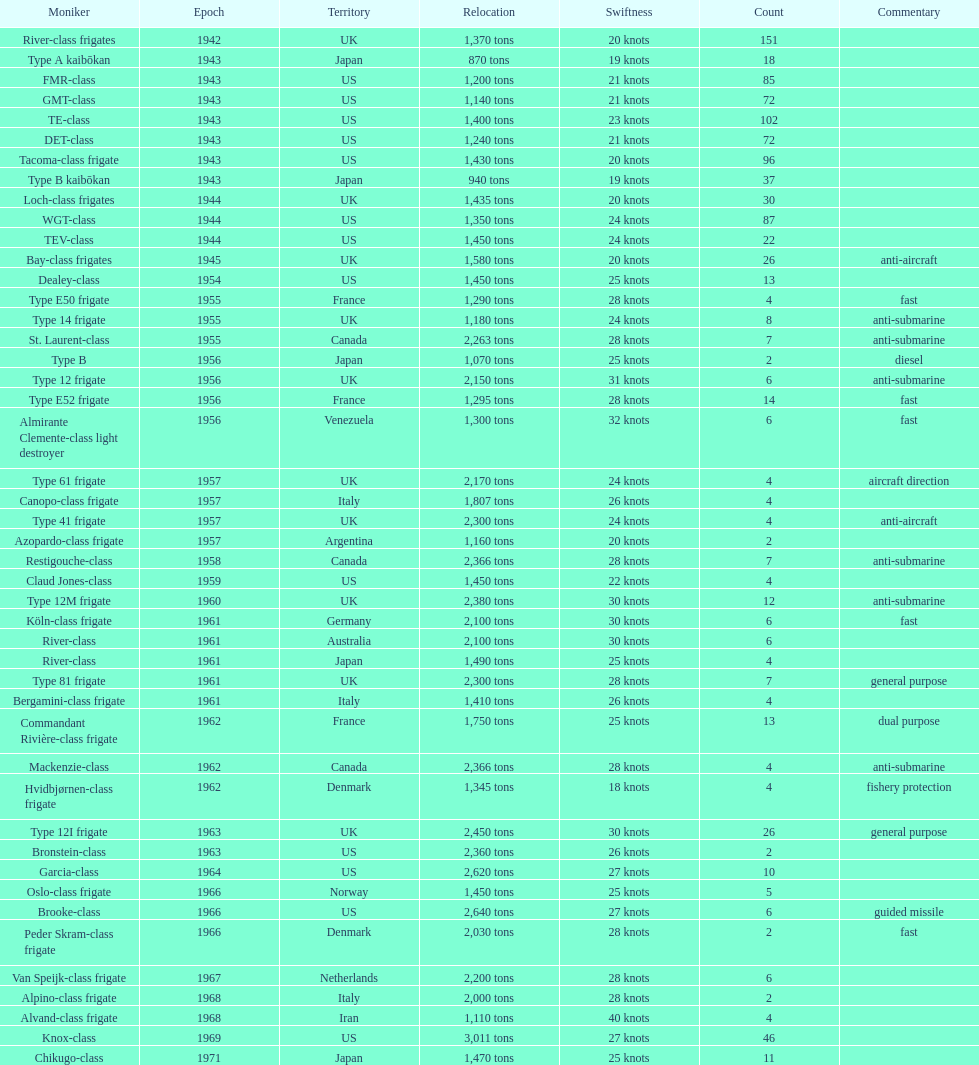Can you parse all the data within this table? {'header': ['Moniker', 'Epoch', 'Territory', 'Relocation', 'Swiftness', 'Count', 'Commentary'], 'rows': [['River-class frigates', '1942', 'UK', '1,370 tons', '20 knots', '151', ''], ['Type A kaibōkan', '1943', 'Japan', '870 tons', '19 knots', '18', ''], ['FMR-class', '1943', 'US', '1,200 tons', '21 knots', '85', ''], ['GMT-class', '1943', 'US', '1,140 tons', '21 knots', '72', ''], ['TE-class', '1943', 'US', '1,400 tons', '23 knots', '102', ''], ['DET-class', '1943', 'US', '1,240 tons', '21 knots', '72', ''], ['Tacoma-class frigate', '1943', 'US', '1,430 tons', '20 knots', '96', ''], ['Type B kaibōkan', '1943', 'Japan', '940 tons', '19 knots', '37', ''], ['Loch-class frigates', '1944', 'UK', '1,435 tons', '20 knots', '30', ''], ['WGT-class', '1944', 'US', '1,350 tons', '24 knots', '87', ''], ['TEV-class', '1944', 'US', '1,450 tons', '24 knots', '22', ''], ['Bay-class frigates', '1945', 'UK', '1,580 tons', '20 knots', '26', 'anti-aircraft'], ['Dealey-class', '1954', 'US', '1,450 tons', '25 knots', '13', ''], ['Type E50 frigate', '1955', 'France', '1,290 tons', '28 knots', '4', 'fast'], ['Type 14 frigate', '1955', 'UK', '1,180 tons', '24 knots', '8', 'anti-submarine'], ['St. Laurent-class', '1955', 'Canada', '2,263 tons', '28 knots', '7', 'anti-submarine'], ['Type B', '1956', 'Japan', '1,070 tons', '25 knots', '2', 'diesel'], ['Type 12 frigate', '1956', 'UK', '2,150 tons', '31 knots', '6', 'anti-submarine'], ['Type E52 frigate', '1956', 'France', '1,295 tons', '28 knots', '14', 'fast'], ['Almirante Clemente-class light destroyer', '1956', 'Venezuela', '1,300 tons', '32 knots', '6', 'fast'], ['Type 61 frigate', '1957', 'UK', '2,170 tons', '24 knots', '4', 'aircraft direction'], ['Canopo-class frigate', '1957', 'Italy', '1,807 tons', '26 knots', '4', ''], ['Type 41 frigate', '1957', 'UK', '2,300 tons', '24 knots', '4', 'anti-aircraft'], ['Azopardo-class frigate', '1957', 'Argentina', '1,160 tons', '20 knots', '2', ''], ['Restigouche-class', '1958', 'Canada', '2,366 tons', '28 knots', '7', 'anti-submarine'], ['Claud Jones-class', '1959', 'US', '1,450 tons', '22 knots', '4', ''], ['Type 12M frigate', '1960', 'UK', '2,380 tons', '30 knots', '12', 'anti-submarine'], ['Köln-class frigate', '1961', 'Germany', '2,100 tons', '30 knots', '6', 'fast'], ['River-class', '1961', 'Australia', '2,100 tons', '30 knots', '6', ''], ['River-class', '1961', 'Japan', '1,490 tons', '25 knots', '4', ''], ['Type 81 frigate', '1961', 'UK', '2,300 tons', '28 knots', '7', 'general purpose'], ['Bergamini-class frigate', '1961', 'Italy', '1,410 tons', '26 knots', '4', ''], ['Commandant Rivière-class frigate', '1962', 'France', '1,750 tons', '25 knots', '13', 'dual purpose'], ['Mackenzie-class', '1962', 'Canada', '2,366 tons', '28 knots', '4', 'anti-submarine'], ['Hvidbjørnen-class frigate', '1962', 'Denmark', '1,345 tons', '18 knots', '4', 'fishery protection'], ['Type 12I frigate', '1963', 'UK', '2,450 tons', '30 knots', '26', 'general purpose'], ['Bronstein-class', '1963', 'US', '2,360 tons', '26 knots', '2', ''], ['Garcia-class', '1964', 'US', '2,620 tons', '27 knots', '10', ''], ['Oslo-class frigate', '1966', 'Norway', '1,450 tons', '25 knots', '5', ''], ['Brooke-class', '1966', 'US', '2,640 tons', '27 knots', '6', 'guided missile'], ['Peder Skram-class frigate', '1966', 'Denmark', '2,030 tons', '28 knots', '2', 'fast'], ['Van Speijk-class frigate', '1967', 'Netherlands', '2,200 tons', '28 knots', '6', ''], ['Alpino-class frigate', '1968', 'Italy', '2,000 tons', '28 knots', '2', ''], ['Alvand-class frigate', '1968', 'Iran', '1,110 tons', '40 knots', '4', ''], ['Knox-class', '1969', 'US', '3,011 tons', '27 knots', '46', ''], ['Chikugo-class', '1971', 'Japan', '1,470 tons', '25 knots', '11', '']]} Which name has the largest displacement? Knox-class. 